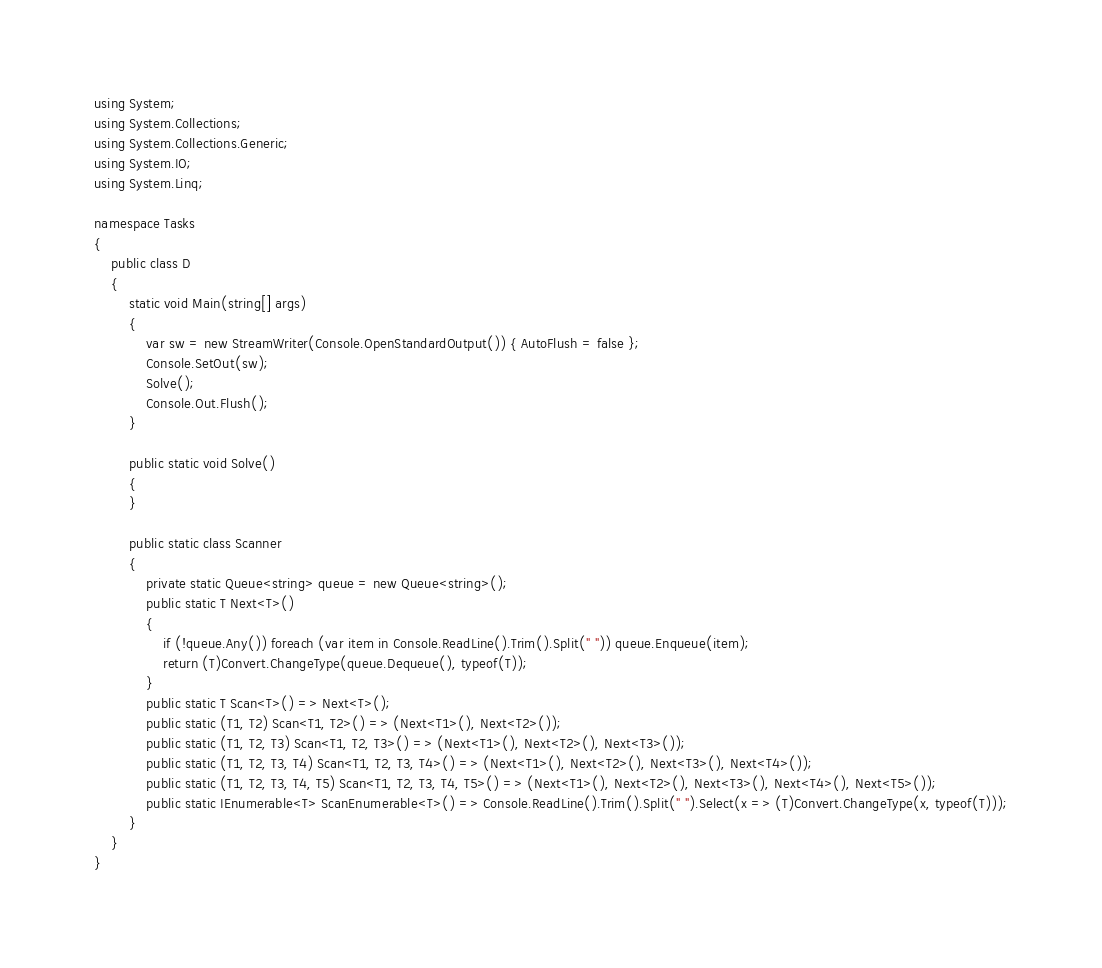Convert code to text. <code><loc_0><loc_0><loc_500><loc_500><_C#_>using System;
using System.Collections;
using System.Collections.Generic;
using System.IO;
using System.Linq;

namespace Tasks
{
    public class D
    {
        static void Main(string[] args)
        {
            var sw = new StreamWriter(Console.OpenStandardOutput()) { AutoFlush = false };
            Console.SetOut(sw);
            Solve();
            Console.Out.Flush();
        }

        public static void Solve()
        {
        }

        public static class Scanner
        {
            private static Queue<string> queue = new Queue<string>();
            public static T Next<T>()
            {
                if (!queue.Any()) foreach (var item in Console.ReadLine().Trim().Split(" ")) queue.Enqueue(item);
                return (T)Convert.ChangeType(queue.Dequeue(), typeof(T));
            }
            public static T Scan<T>() => Next<T>();
            public static (T1, T2) Scan<T1, T2>() => (Next<T1>(), Next<T2>());
            public static (T1, T2, T3) Scan<T1, T2, T3>() => (Next<T1>(), Next<T2>(), Next<T3>());
            public static (T1, T2, T3, T4) Scan<T1, T2, T3, T4>() => (Next<T1>(), Next<T2>(), Next<T3>(), Next<T4>());
            public static (T1, T2, T3, T4, T5) Scan<T1, T2, T3, T4, T5>() => (Next<T1>(), Next<T2>(), Next<T3>(), Next<T4>(), Next<T5>());
            public static IEnumerable<T> ScanEnumerable<T>() => Console.ReadLine().Trim().Split(" ").Select(x => (T)Convert.ChangeType(x, typeof(T)));
        }
    }
}
</code> 